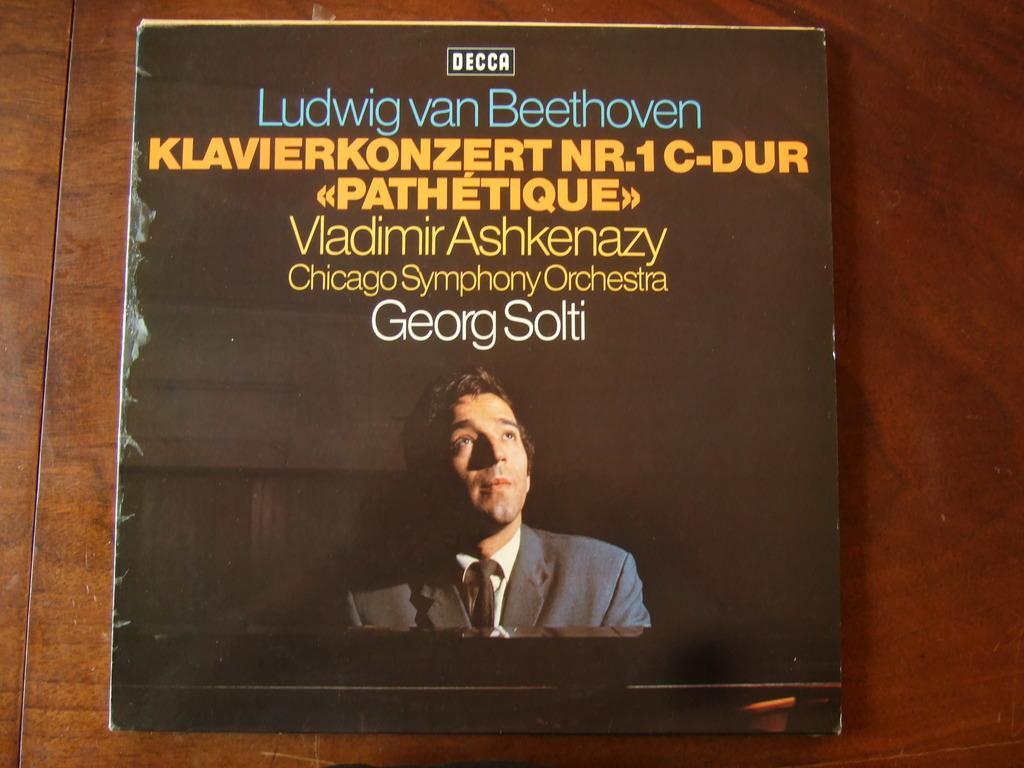Describe this image in one or two sentences. In this image we can see a cover of a book on which a person's photo and a text are present on it. 